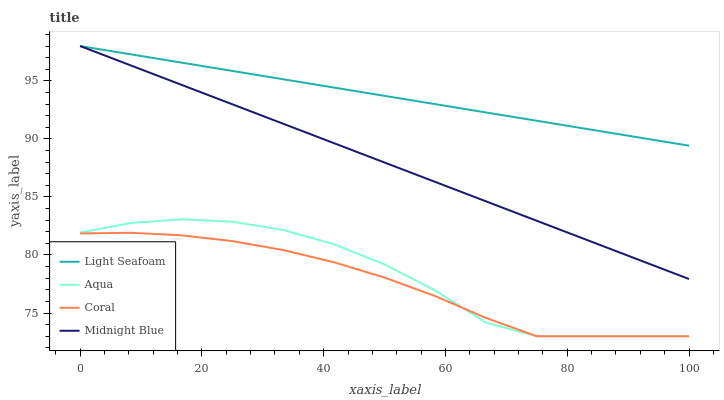Does Coral have the minimum area under the curve?
Answer yes or no. Yes. Does Light Seafoam have the maximum area under the curve?
Answer yes or no. Yes. Does Aqua have the minimum area under the curve?
Answer yes or no. No. Does Aqua have the maximum area under the curve?
Answer yes or no. No. Is Midnight Blue the smoothest?
Answer yes or no. Yes. Is Aqua the roughest?
Answer yes or no. Yes. Is Light Seafoam the smoothest?
Answer yes or no. No. Is Light Seafoam the roughest?
Answer yes or no. No. Does Light Seafoam have the lowest value?
Answer yes or no. No. Does Aqua have the highest value?
Answer yes or no. No. Is Aqua less than Light Seafoam?
Answer yes or no. Yes. Is Midnight Blue greater than Aqua?
Answer yes or no. Yes. Does Aqua intersect Light Seafoam?
Answer yes or no. No. 